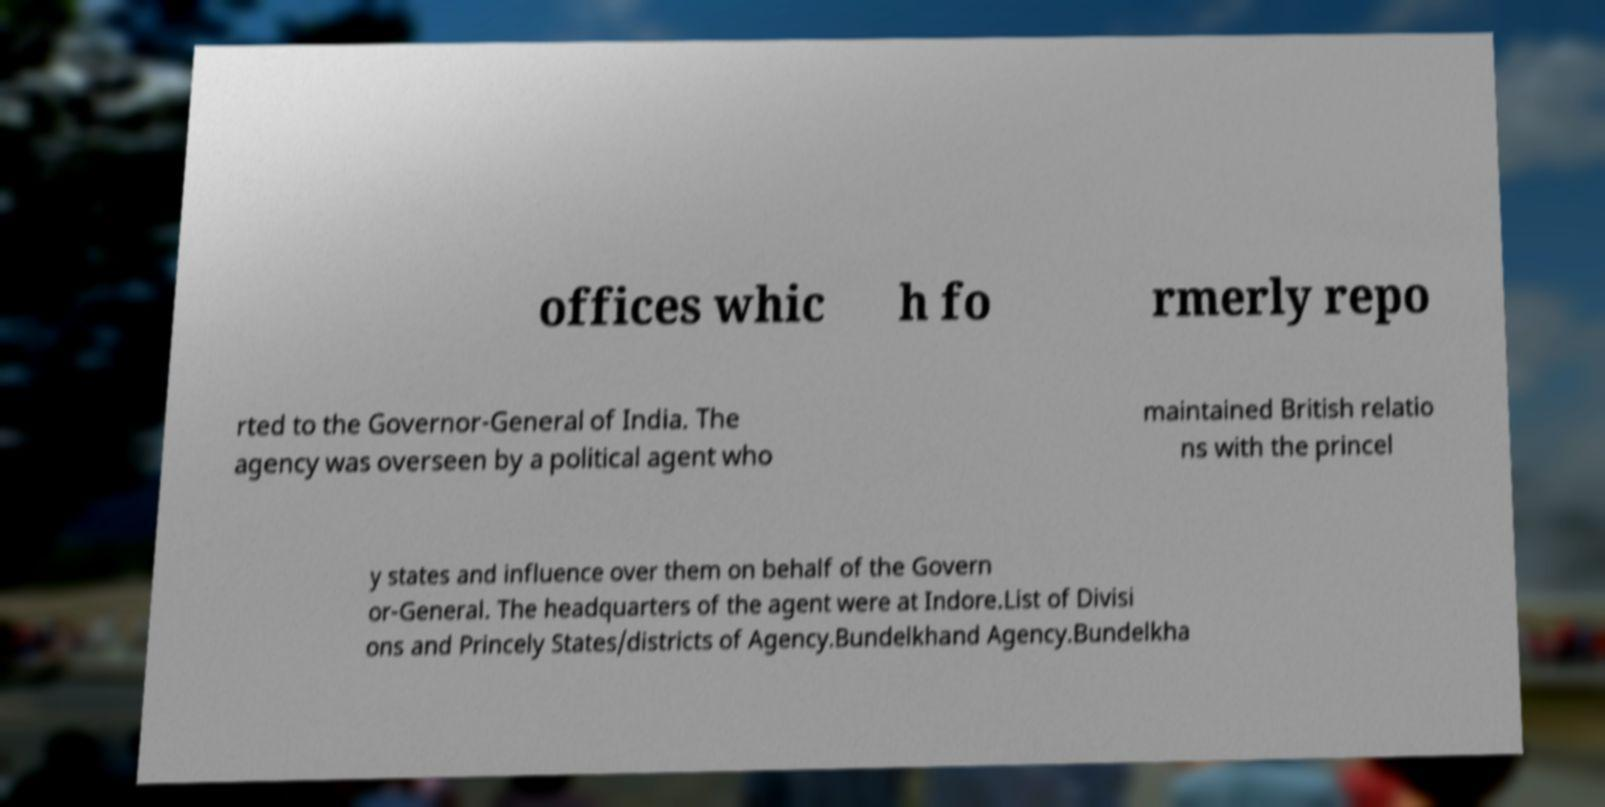Could you assist in decoding the text presented in this image and type it out clearly? offices whic h fo rmerly repo rted to the Governor-General of India. The agency was overseen by a political agent who maintained British relatio ns with the princel y states and influence over them on behalf of the Govern or-General. The headquarters of the agent were at Indore.List of Divisi ons and Princely States/districts of Agency.Bundelkhand Agency.Bundelkha 